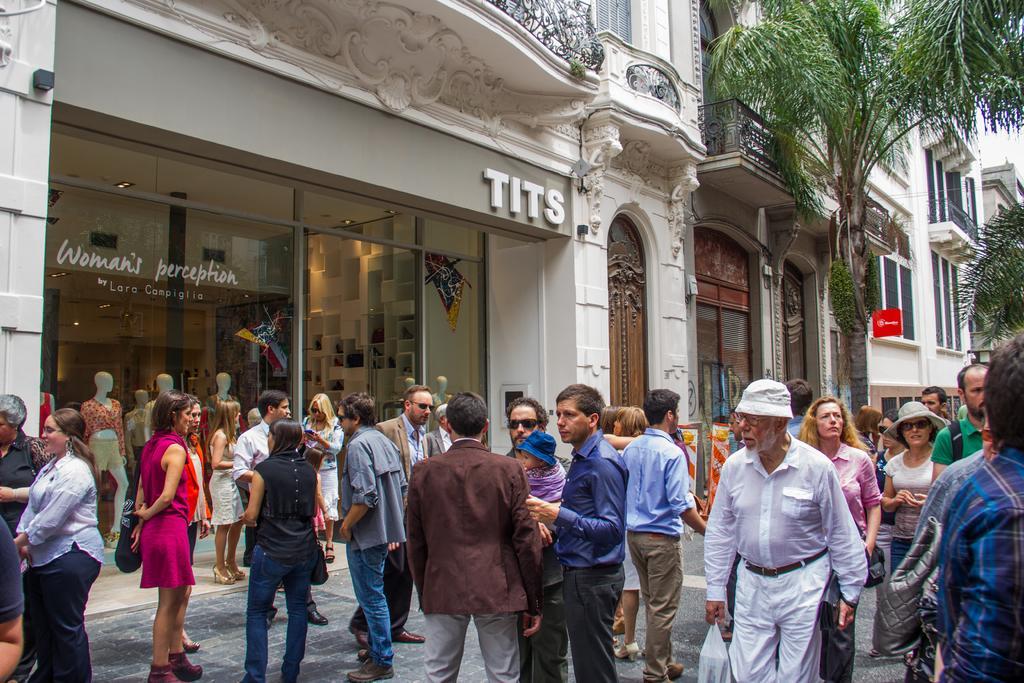How would you summarize this image in a sentence or two? In this image there are people doing different activities, in the background there is a shop and there are trees. 